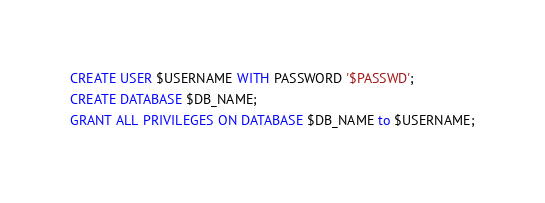Convert code to text. <code><loc_0><loc_0><loc_500><loc_500><_SQL_>CREATE USER $USERNAME WITH PASSWORD '$PASSWD';
CREATE DATABASE $DB_NAME;
GRANT ALL PRIVILEGES ON DATABASE $DB_NAME to $USERNAME;
</code> 